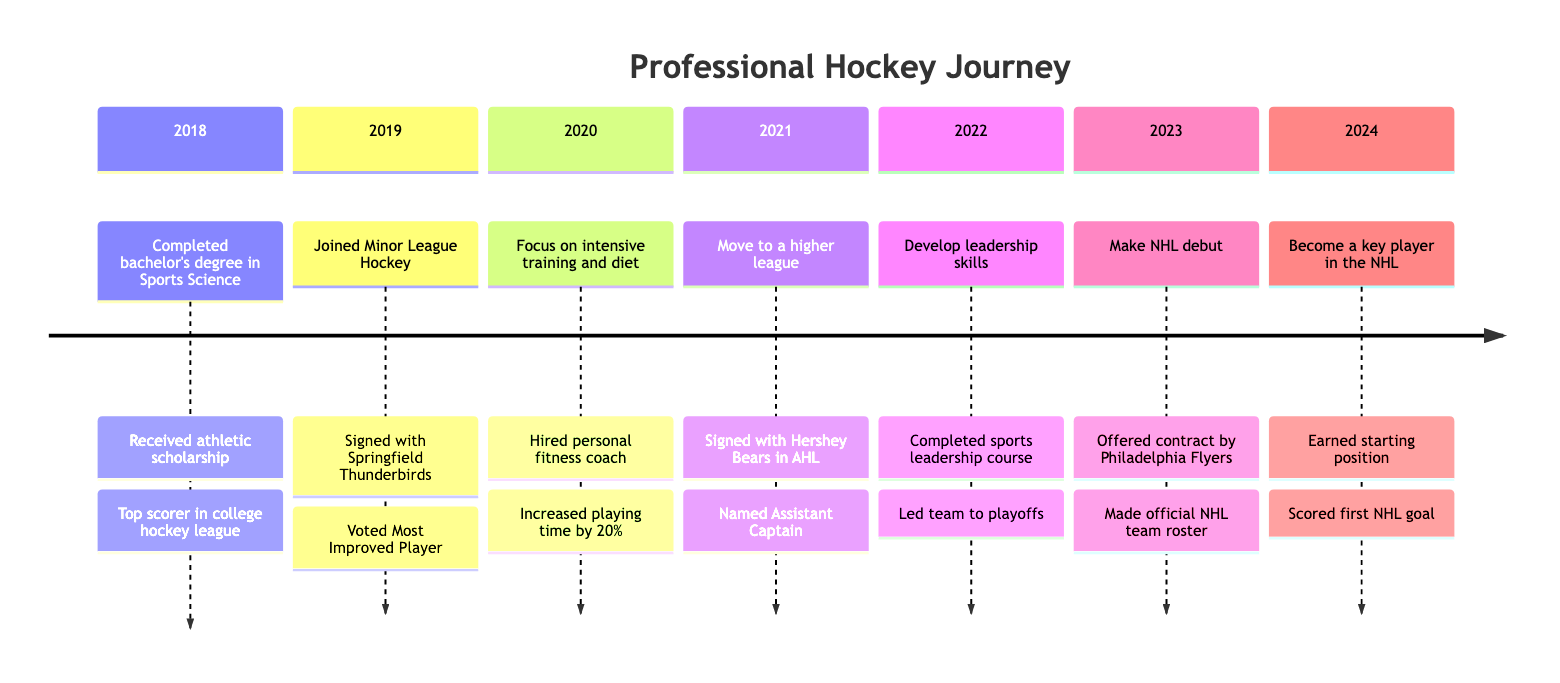What was the personal goal in 2020? In 2020, the personal goal was "Focus on intensive training and diet," which can be found in that section of the timeline.
Answer: Focus on intensive training and diet How many milestones are listed in the timeline? The timeline contains a total of 7 milestones, one for each year from 2018 to 2024, which can be tallied directly from the sections of the diagram.
Answer: 7 What achievement was recognized in 2021? The achievement in 2021 was "Named Assistant Captain," which appears as the second achievement listed under that year on the timeline.
Answer: Named Assistant Captain Which year did the individual make their NHL debut? The NHL debut was made in 2023, as noted in that year's section of the timeline.
Answer: 2023 What was the milestone achieved in 2022? In 2022, the milestone was "Completed sports leadership course," identified in that year's timeline details.
Answer: Completed sports leadership course In which year did the player become the top scorer in the college hockey league? The player became the top scorer in the college hockey league in 2018, which is indicated in that section of the timeline.
Answer: 2018 How is the progression from Minor League Hockey to AHL represented in the timeline? The progression shows the transition from "Joined Minor League Hockey" in 2019 to "Signed with Hershey Bears in AHL" in 2021, indicating the move to a higher league.
Answer: Progression from 2019 to 2021 What is the last achievement noted in the timeline? The last achievement noted in the timeline is "Scored first NHL goal," which is found under the 2024 section.
Answer: Scored first NHL goal 